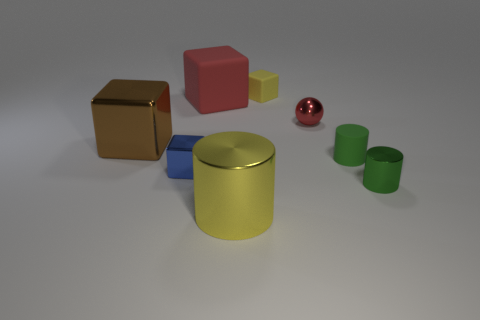What time of day does the lighting suggest? The lighting in the image is soft and diffused, lacking any strong shadows that would suggest a particular time of day. It is likely studio lighting used to illuminate the objects evenly. 